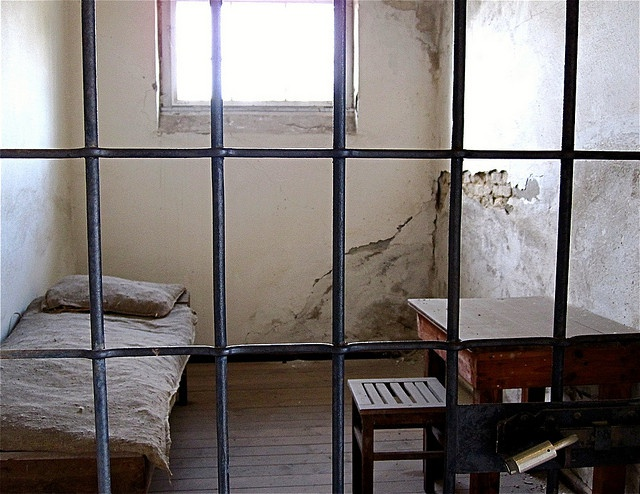Describe the objects in this image and their specific colors. I can see bed in white, gray, and black tones and chair in white, black, darkgray, and gray tones in this image. 